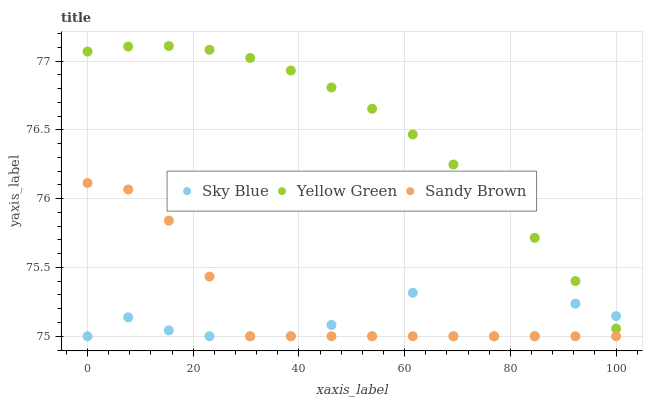Does Sky Blue have the minimum area under the curve?
Answer yes or no. Yes. Does Yellow Green have the maximum area under the curve?
Answer yes or no. Yes. Does Sandy Brown have the minimum area under the curve?
Answer yes or no. No. Does Sandy Brown have the maximum area under the curve?
Answer yes or no. No. Is Yellow Green the smoothest?
Answer yes or no. Yes. Is Sky Blue the roughest?
Answer yes or no. Yes. Is Sandy Brown the smoothest?
Answer yes or no. No. Is Sandy Brown the roughest?
Answer yes or no. No. Does Sky Blue have the lowest value?
Answer yes or no. Yes. Does Yellow Green have the lowest value?
Answer yes or no. No. Does Yellow Green have the highest value?
Answer yes or no. Yes. Does Sandy Brown have the highest value?
Answer yes or no. No. Is Sandy Brown less than Yellow Green?
Answer yes or no. Yes. Is Yellow Green greater than Sandy Brown?
Answer yes or no. Yes. Does Sky Blue intersect Sandy Brown?
Answer yes or no. Yes. Is Sky Blue less than Sandy Brown?
Answer yes or no. No. Is Sky Blue greater than Sandy Brown?
Answer yes or no. No. Does Sandy Brown intersect Yellow Green?
Answer yes or no. No. 